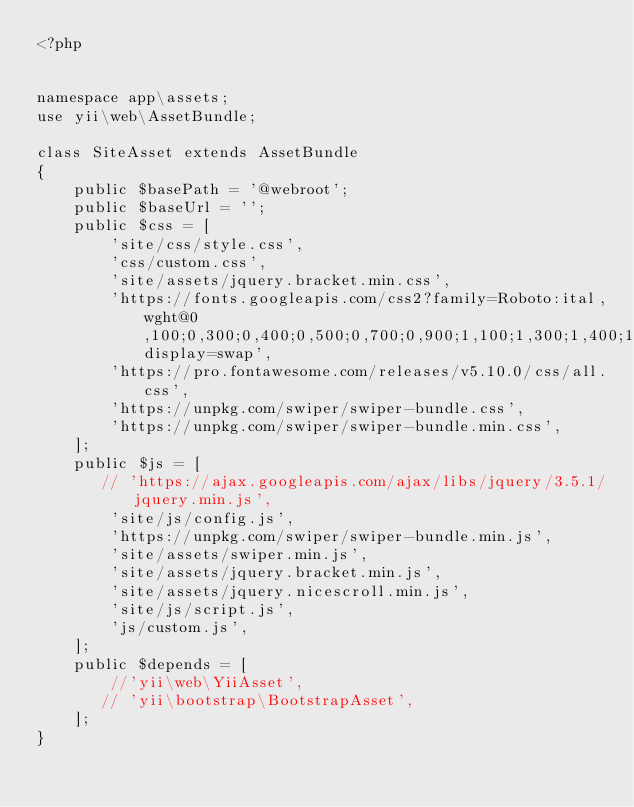<code> <loc_0><loc_0><loc_500><loc_500><_PHP_><?php


namespace app\assets;
use yii\web\AssetBundle;

class SiteAsset extends AssetBundle
{
    public $basePath = '@webroot';
    public $baseUrl = '';
    public $css = [
        'site/css/style.css',
        'css/custom.css',
        'site/assets/jquery.bracket.min.css',
        'https://fonts.googleapis.com/css2?family=Roboto:ital,wght@0,100;0,300;0,400;0,500;0,700;0,900;1,100;1,300;1,400;1,500;1,700;1,900&display=swap',
        'https://pro.fontawesome.com/releases/v5.10.0/css/all.css',
        'https://unpkg.com/swiper/swiper-bundle.css',
        'https://unpkg.com/swiper/swiper-bundle.min.css',
    ];
    public $js = [
       // 'https://ajax.googleapis.com/ajax/libs/jquery/3.5.1/jquery.min.js',
        'site/js/config.js',
        'https://unpkg.com/swiper/swiper-bundle.min.js',
        'site/assets/swiper.min.js',
        'site/assets/jquery.bracket.min.js',
        'site/assets/jquery.nicescroll.min.js',
        'site/js/script.js',
        'js/custom.js',
    ];
    public $depends = [
        //'yii\web\YiiAsset',
       // 'yii\bootstrap\BootstrapAsset',
    ];
}</code> 